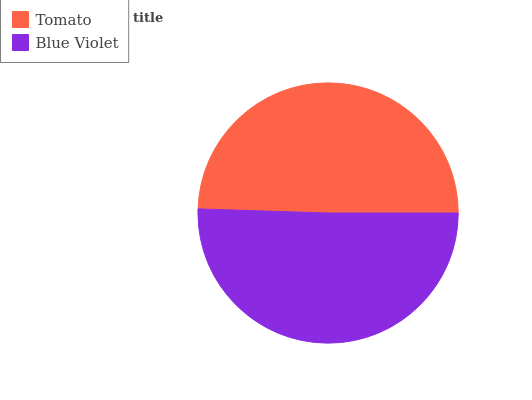Is Tomato the minimum?
Answer yes or no. Yes. Is Blue Violet the maximum?
Answer yes or no. Yes. Is Blue Violet the minimum?
Answer yes or no. No. Is Blue Violet greater than Tomato?
Answer yes or no. Yes. Is Tomato less than Blue Violet?
Answer yes or no. Yes. Is Tomato greater than Blue Violet?
Answer yes or no. No. Is Blue Violet less than Tomato?
Answer yes or no. No. Is Blue Violet the high median?
Answer yes or no. Yes. Is Tomato the low median?
Answer yes or no. Yes. Is Tomato the high median?
Answer yes or no. No. Is Blue Violet the low median?
Answer yes or no. No. 